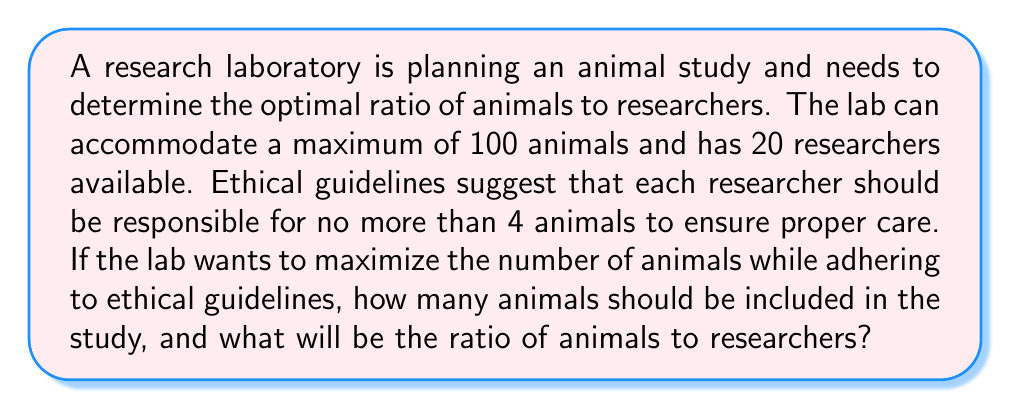Show me your answer to this math problem. Let's approach this step-by-step:

1) First, we need to identify the constraints:
   - Maximum capacity: 100 animals
   - Available researchers: 20
   - Ethical guideline: ≤ 4 animals per researcher

2) To find the maximum number of animals while adhering to the ethical guideline:
   $$ \text{Max animals} = \text{Number of researchers} \times \text{Max animals per researcher} $$
   $$ \text{Max animals} = 20 \times 4 = 80 $$

3) This is less than the laboratory's maximum capacity (100), so it's feasible.

4) To calculate the ratio of animals to researchers:
   $$ \text{Ratio} = \frac{\text{Number of animals}}{\text{Number of researchers}} = \frac{80}{20} = 4:1 $$

5) We can simplify this ratio by dividing both numbers by their greatest common divisor (20):
   $$ \frac{80 \div 20}{20 \div 20} = \frac{4}{1} $$

Therefore, the optimal number of animals for the study is 80, and the simplified ratio of animals to researchers is 4:1.
Answer: 80 animals; 4:1 ratio 